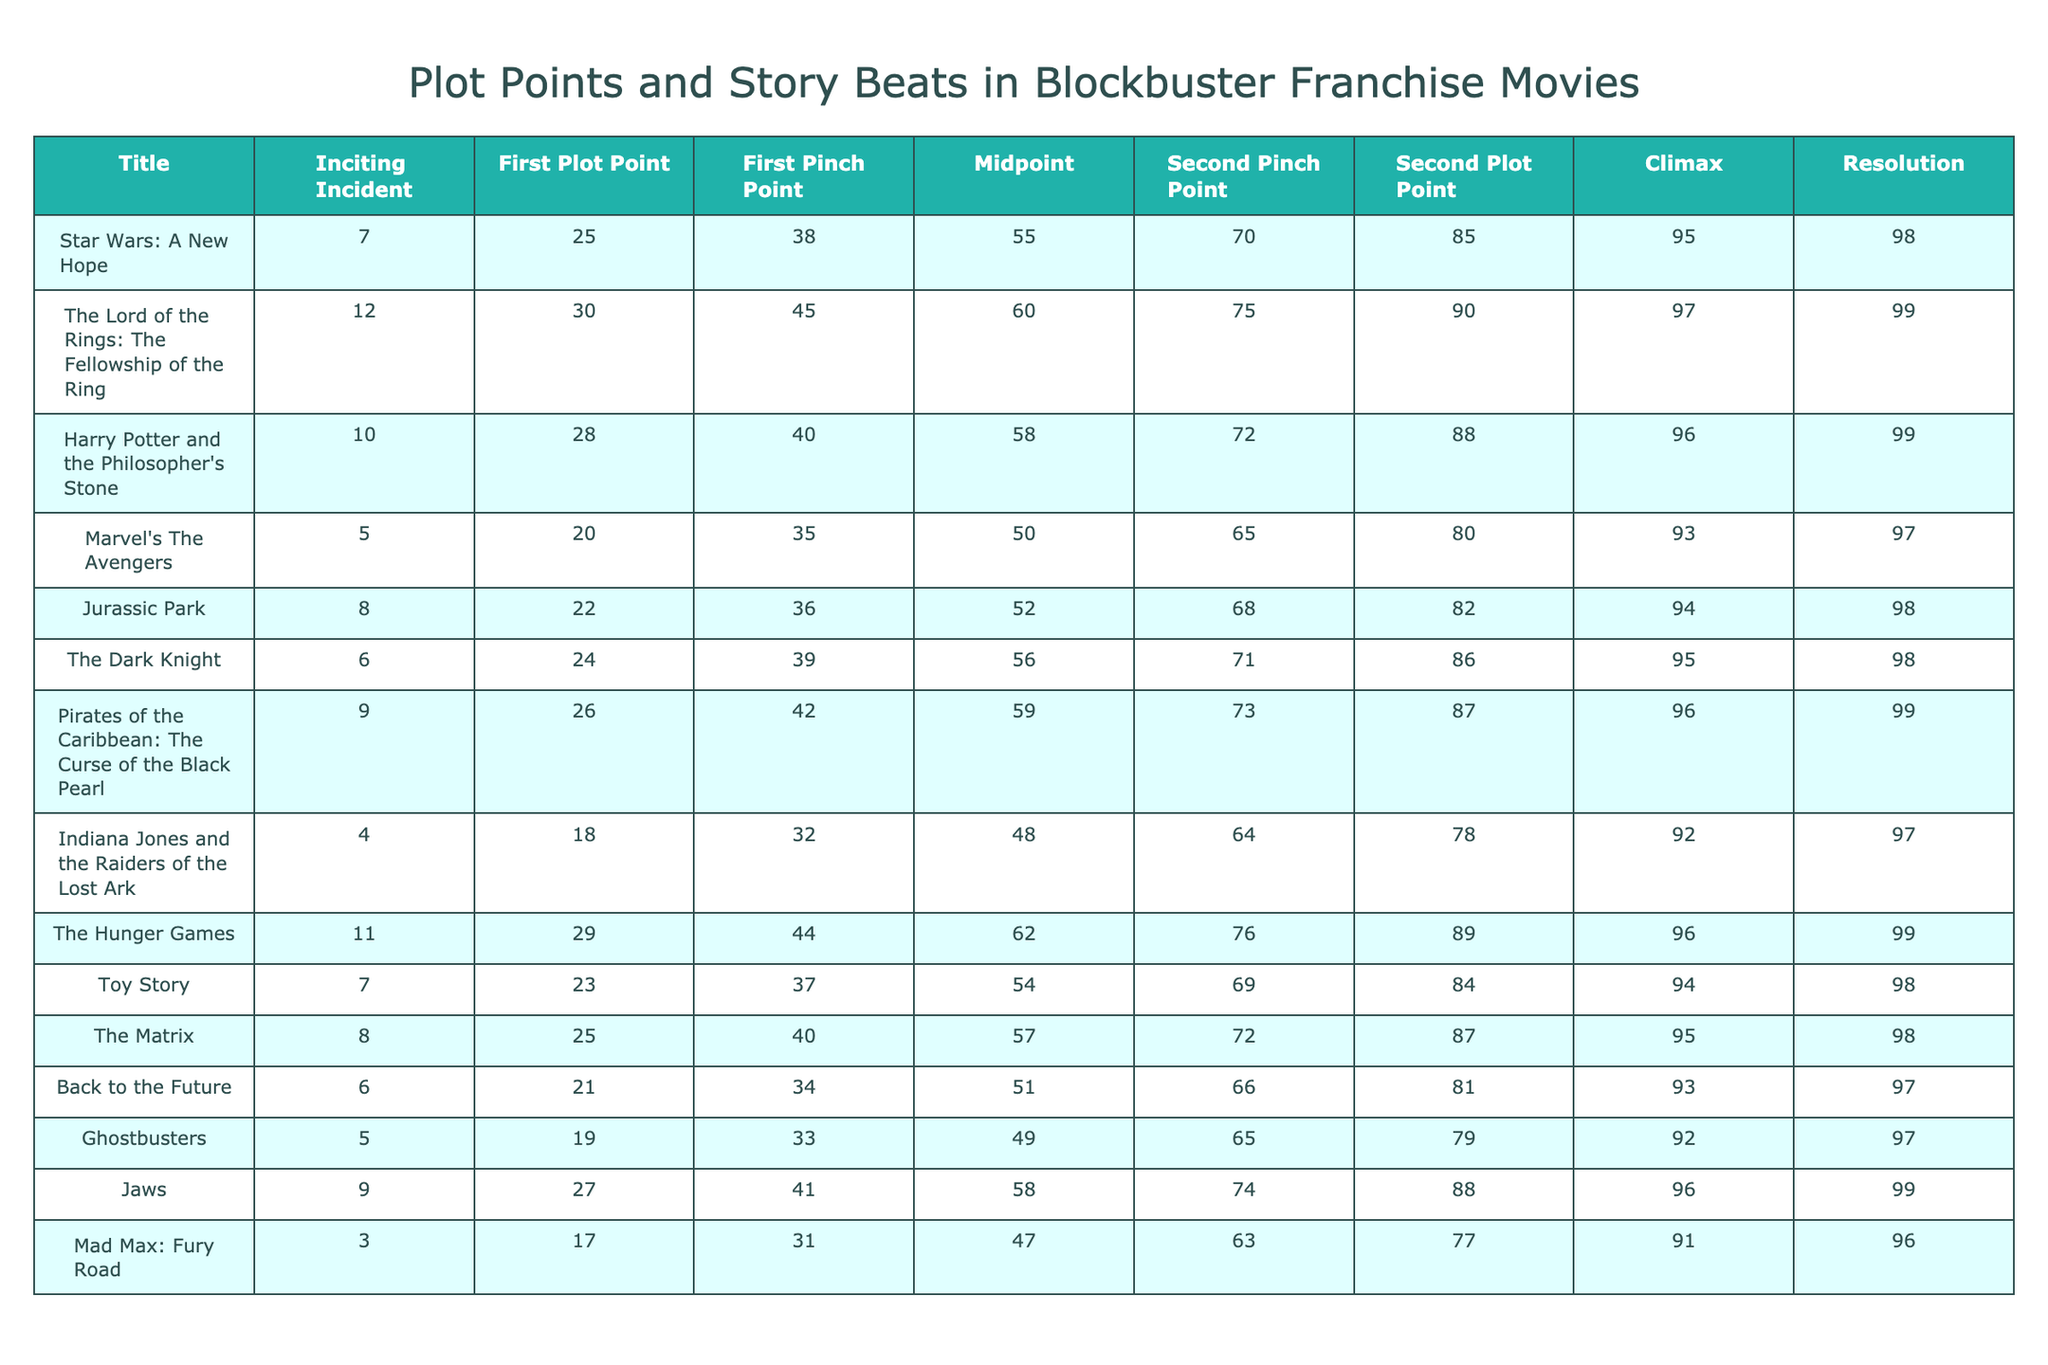What is the Inciting Incident value for "Jurassic Park"? The table shows the specific values for each plot point for every movie. Looking under the "Inciting Incident" column for "Jurassic Park," the value listed is 8.
Answer: 8 Which movie has the highest value for the Midpoint? By examining the "Midpoint" column in the table, "The Lord of the Rings: The Fellowship of the Ring" has the highest Midpoint value at 60.
Answer: The Lord of the Rings: The Fellowship of the Ring What is the average value of the Second Plot Point across all movies? To find the average for the Second Plot Point, we first sum up all the values: 85 + 90 + 88 + 80 + 82 + 86 + 87 + 78 + 89 + 84 + 87 + 81 + 79 + 88 + 77 = 1280. There are 15 movies, so we divide 1280 by 15, which gives approximately 85.33.
Answer: 85.33 Did "Star Wars: A New Hope" have a Climax value higher than 95? Checking the "Climax" column for "Star Wars: A New Hope," the value is 95, which means it is not higher than 95.
Answer: No Which movie has the most consistent placement of story beats, having all values above 90 for Climax and Resolution? We can see which movies have both the Climax and Resolution values greater than 90. Upon inspection, "The Lord of the Rings: The Fellowship of the Ring," "Harry Potter and the Philosopher's Stone," and "Pirates of the Caribbean: The Curse of the Black Pearl" meet this criterion with both Climax and Resolution values at 97 and 99 respectively.
Answer: The Lord of the Rings: The Fellowship of the Ring, Harry Potter and the Philosopher's Stone, Pirates of the Caribbean: The Curse of the Black Pearl What is the difference in the First Plot Point value between "The Hunger Games" and "Indiana Jones and the Raiders of the Lost Ark"? We need to find the First Plot Point values for each of those movies. "The Hunger Games" has a value of 29, and "Indiana Jones and the Raiders of the Lost Ark" has a value of 18. The difference is 29 - 18 = 11.
Answer: 11 What percentage of films have a Midpoint value of 55 or higher? First, we can find the number of films with a Midpoint value of 55 or higher: "Star Wars: A New Hope," "The Lord of the Rings: The Fellowship of the Ring," "Harry Potter and the Philosopher's Stone," "Jurassic Park," "The Dark Knight," "Pirates of the Caribbean: The Curse of the Black Pearl," "The Hunger Games," "Toy Story," "The Matrix," and "Back to the Future" all qualify, totaling 10 out of 15 films. To get the percentage, we take (10/15)*100 = 66.67%.
Answer: 66.67% Which two plot points appear most frequently as the highest numbers among the different movies? By observing the table, we note the highest Second Plot Point is 90, and the highest Climax is 99. The second plot points (85, 90, 88, 80 etc.) and climax values are well spread, but "Pirates of the Caribbean" and "Harry Potter" movies have the top values in multiple instances.
Answer: Second Plot Point: 90, Climax: 99 Which movie has the earliest Second Pinch Point? To find the earliest Second Pinch Point, we scan the "Second Pinch Point" column. The earliest value is from "Mad Max: Fury Road," which has a Second Pinch Point at 63.
Answer: Mad Max: Fury Road 